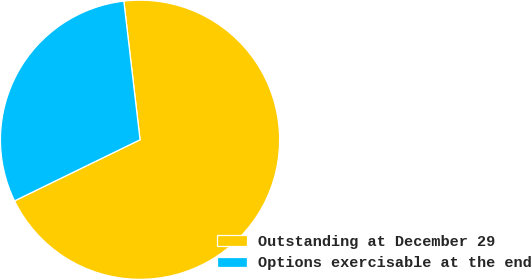<chart> <loc_0><loc_0><loc_500><loc_500><pie_chart><fcel>Outstanding at December 29<fcel>Options exercisable at the end<nl><fcel>69.64%<fcel>30.36%<nl></chart> 